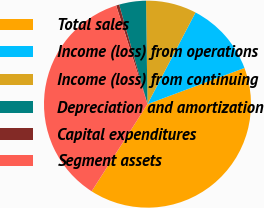<chart> <loc_0><loc_0><loc_500><loc_500><pie_chart><fcel>Total sales<fcel>Income (loss) from operations<fcel>Income (loss) from continuing<fcel>Depreciation and amortization<fcel>Capital expenditures<fcel>Segment assets<nl><fcel>39.76%<fcel>11.63%<fcel>7.91%<fcel>4.19%<fcel>0.47%<fcel>36.04%<nl></chart> 